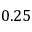<formula> <loc_0><loc_0><loc_500><loc_500>0 . 2 5</formula> 